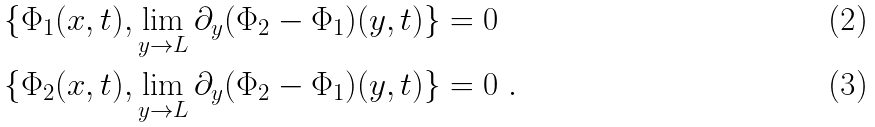<formula> <loc_0><loc_0><loc_500><loc_500>\{ \Phi _ { 1 } ( x , t ) , \lim _ { y \to L } \partial _ { y } ( \Phi _ { 2 } - \Phi _ { 1 } ) ( y , t ) \} & = 0 \\ \{ \Phi _ { 2 } ( x , t ) , \lim _ { y \to L } \partial _ { y } ( \Phi _ { 2 } - \Phi _ { 1 } ) ( y , t ) \} & = 0 \ .</formula> 